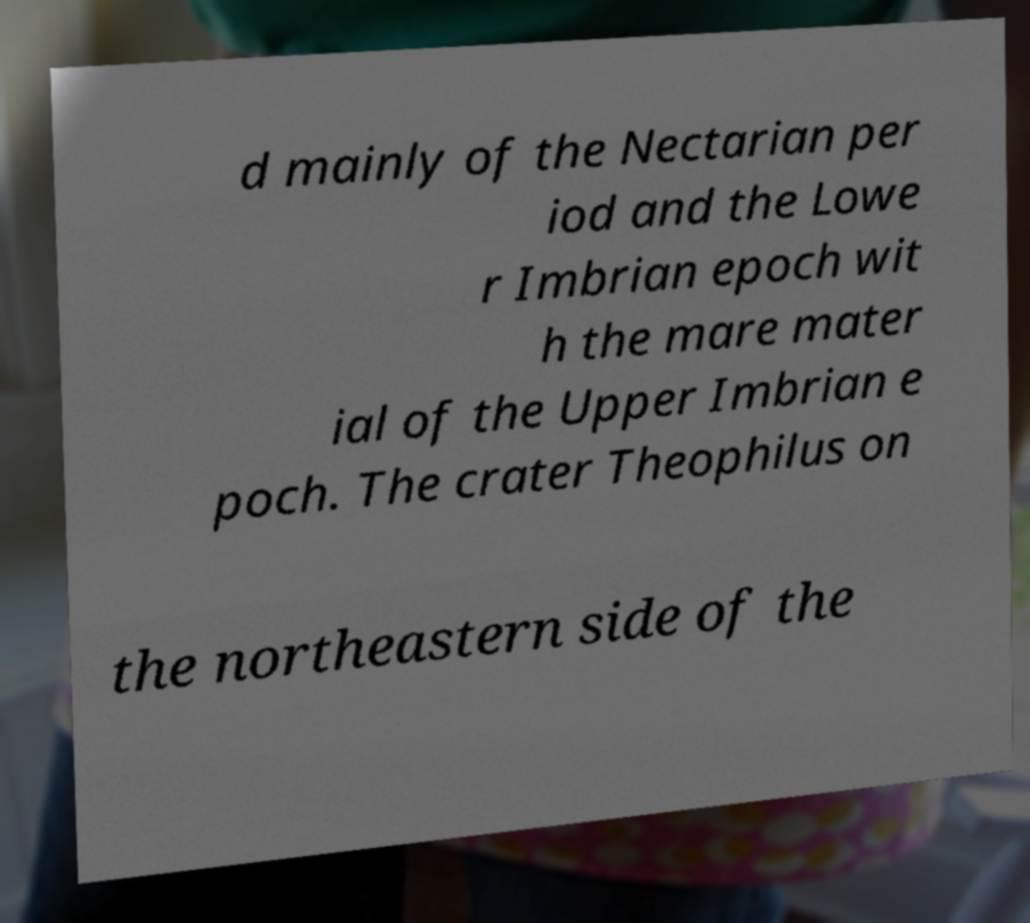Please identify and transcribe the text found in this image. d mainly of the Nectarian per iod and the Lowe r Imbrian epoch wit h the mare mater ial of the Upper Imbrian e poch. The crater Theophilus on the northeastern side of the 